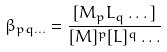<formula> <loc_0><loc_0><loc_500><loc_500>\beta _ { p q \dots } = \frac { [ M _ { p } L _ { q } \dots ] } { [ M ] ^ { p } [ L ] ^ { q } \dots }</formula> 